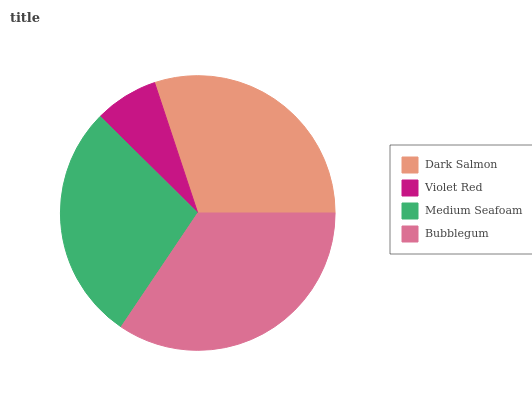Is Violet Red the minimum?
Answer yes or no. Yes. Is Bubblegum the maximum?
Answer yes or no. Yes. Is Medium Seafoam the minimum?
Answer yes or no. No. Is Medium Seafoam the maximum?
Answer yes or no. No. Is Medium Seafoam greater than Violet Red?
Answer yes or no. Yes. Is Violet Red less than Medium Seafoam?
Answer yes or no. Yes. Is Violet Red greater than Medium Seafoam?
Answer yes or no. No. Is Medium Seafoam less than Violet Red?
Answer yes or no. No. Is Dark Salmon the high median?
Answer yes or no. Yes. Is Medium Seafoam the low median?
Answer yes or no. Yes. Is Medium Seafoam the high median?
Answer yes or no. No. Is Dark Salmon the low median?
Answer yes or no. No. 